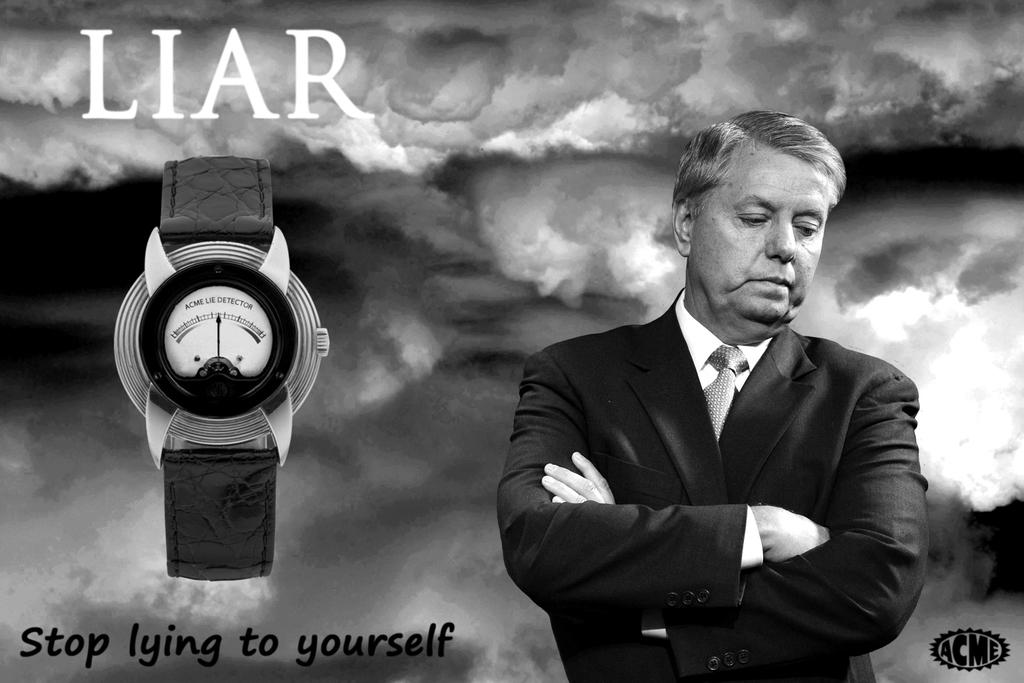<image>
Present a compact description of the photo's key features. An ACME ad for a lie detector one wears on their wrist. 